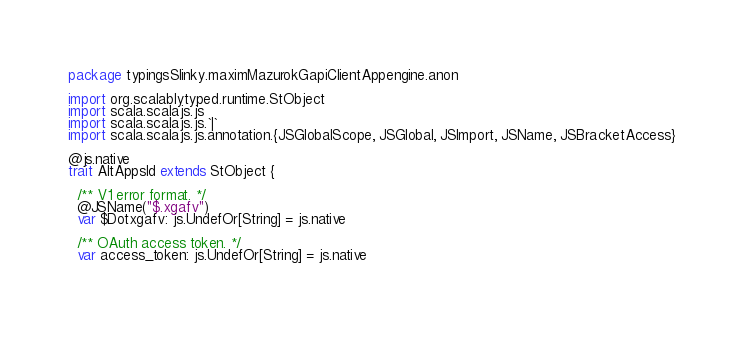Convert code to text. <code><loc_0><loc_0><loc_500><loc_500><_Scala_>package typingsSlinky.maximMazurokGapiClientAppengine.anon

import org.scalablytyped.runtime.StObject
import scala.scalajs.js
import scala.scalajs.js.`|`
import scala.scalajs.js.annotation.{JSGlobalScope, JSGlobal, JSImport, JSName, JSBracketAccess}

@js.native
trait AltAppsId extends StObject {
  
  /** V1 error format. */
  @JSName("$.xgafv")
  var $Dotxgafv: js.UndefOr[String] = js.native
  
  /** OAuth access token. */
  var access_token: js.UndefOr[String] = js.native
  </code> 